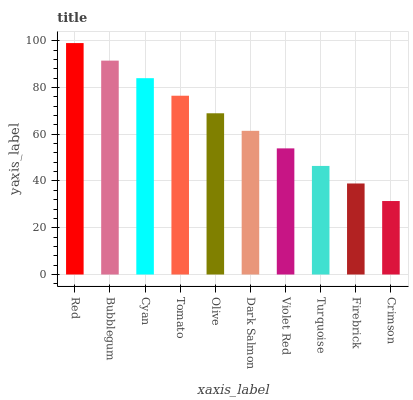Is Bubblegum the minimum?
Answer yes or no. No. Is Bubblegum the maximum?
Answer yes or no. No. Is Red greater than Bubblegum?
Answer yes or no. Yes. Is Bubblegum less than Red?
Answer yes or no. Yes. Is Bubblegum greater than Red?
Answer yes or no. No. Is Red less than Bubblegum?
Answer yes or no. No. Is Olive the high median?
Answer yes or no. Yes. Is Dark Salmon the low median?
Answer yes or no. Yes. Is Cyan the high median?
Answer yes or no. No. Is Bubblegum the low median?
Answer yes or no. No. 